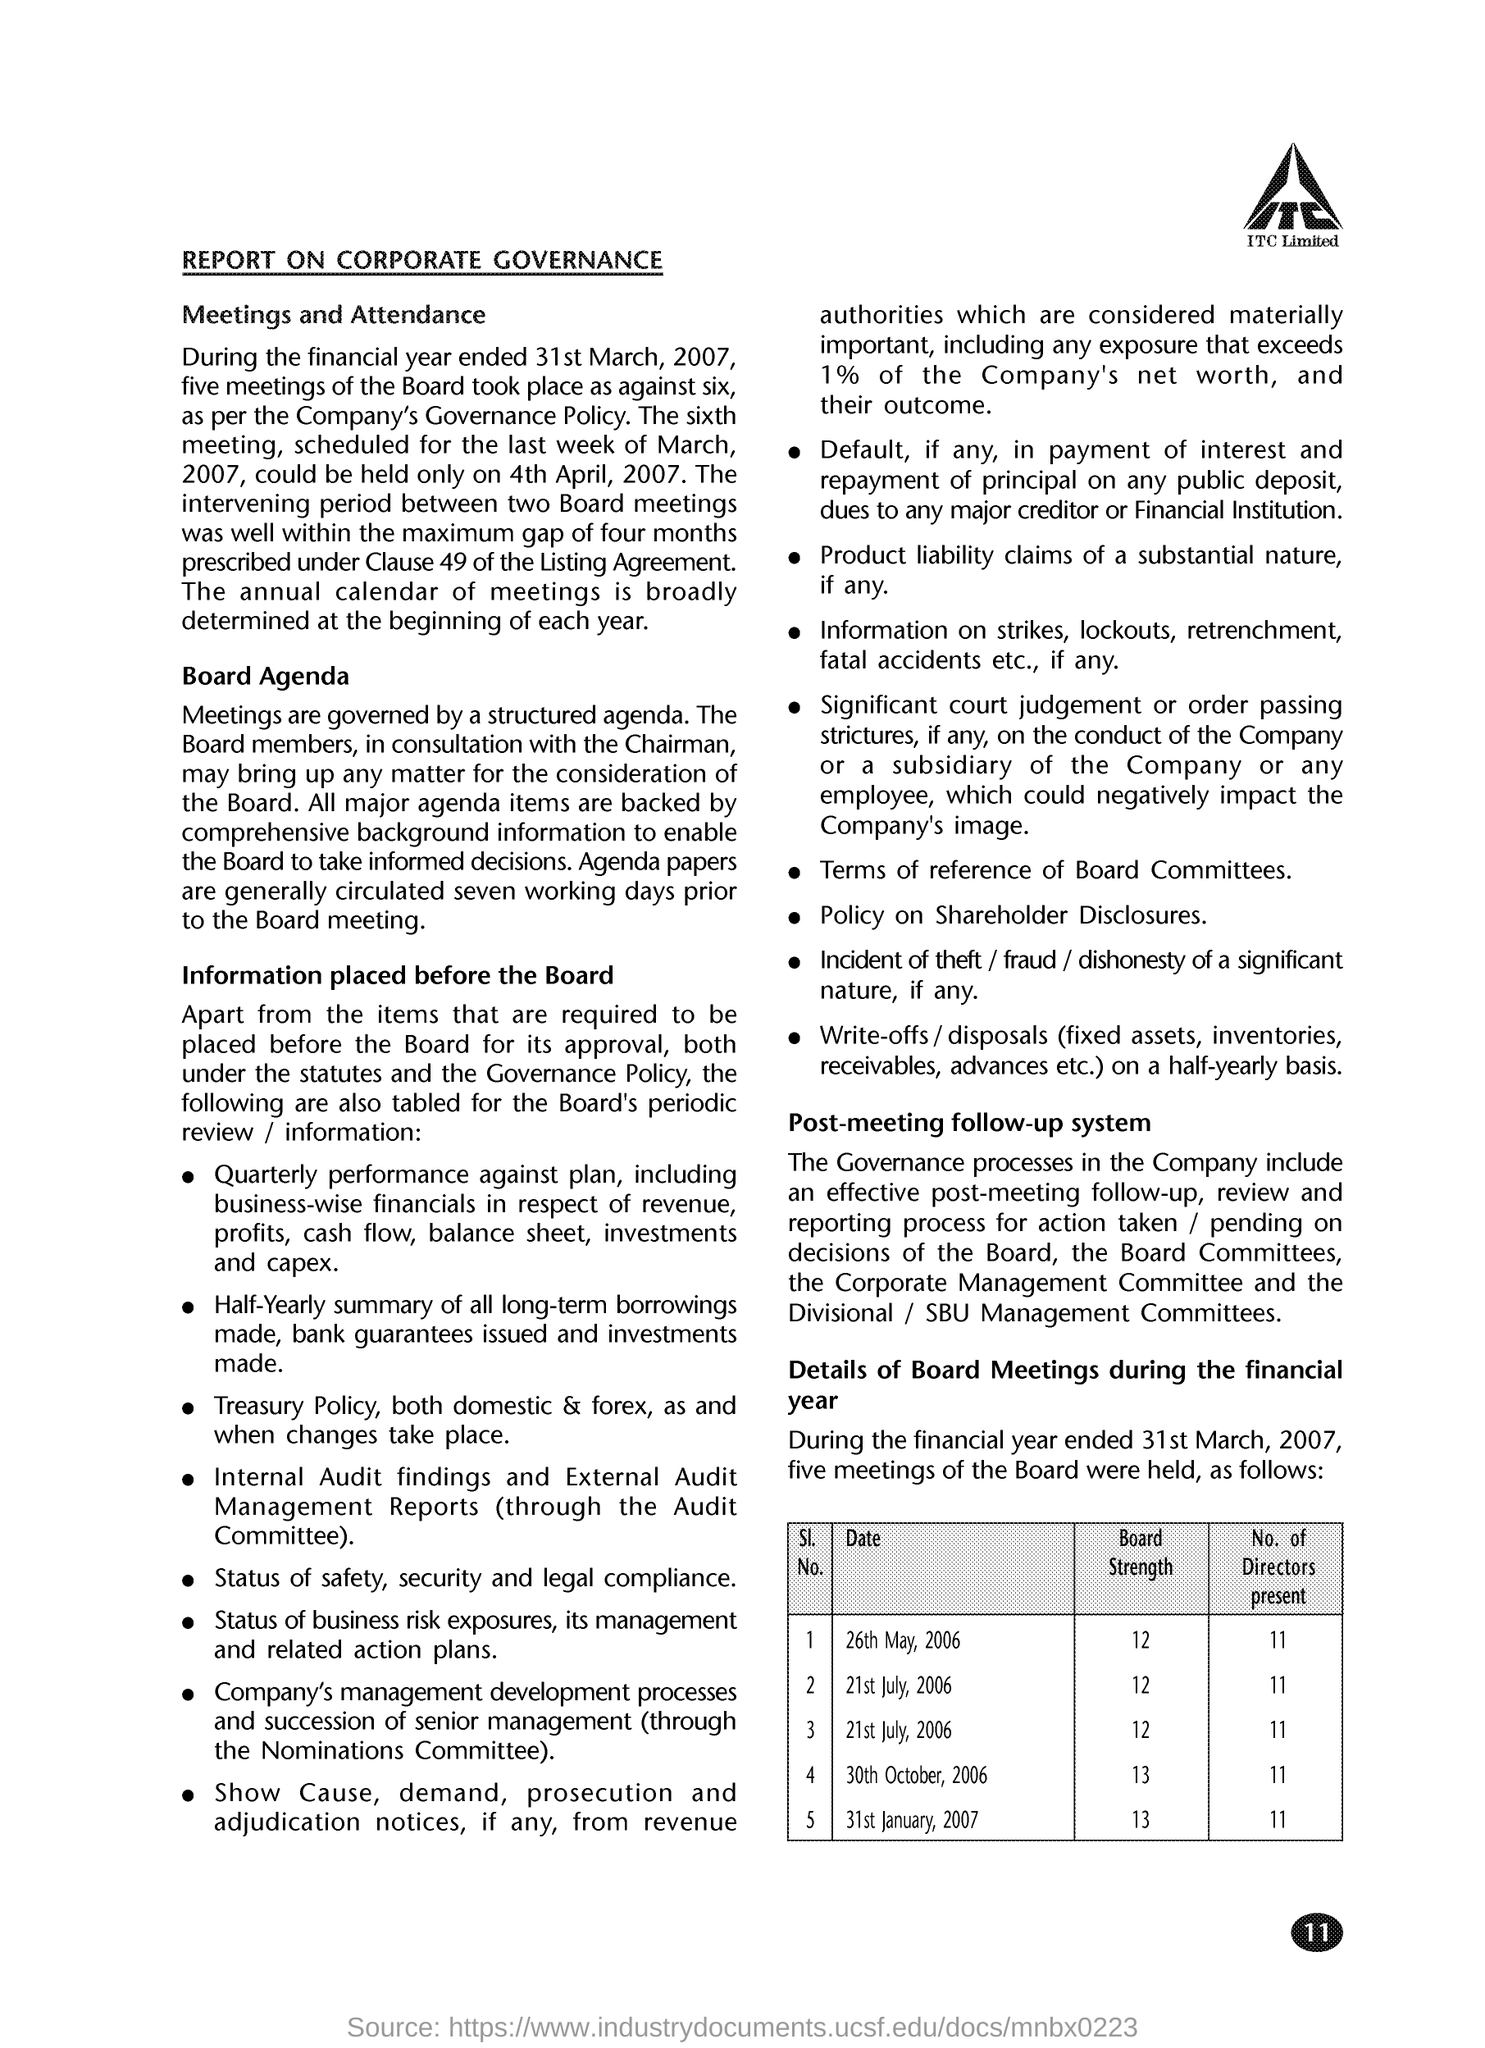Highlight a few significant elements in this photo. What is the Board Strength for May 26, 2006? It is 12. On January 31st, 2007, there were 11 directors present. What is the board strength for the date of October 30th, 2006? It is 13. On July 21st, 2006, the strength of the board was 12. The board strength on January 31st, 2007 was 13. 